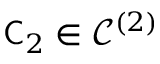Convert formula to latex. <formula><loc_0><loc_0><loc_500><loc_500>\mathsf C _ { 2 } \in \mathcal { C } ^ { ( 2 ) }</formula> 